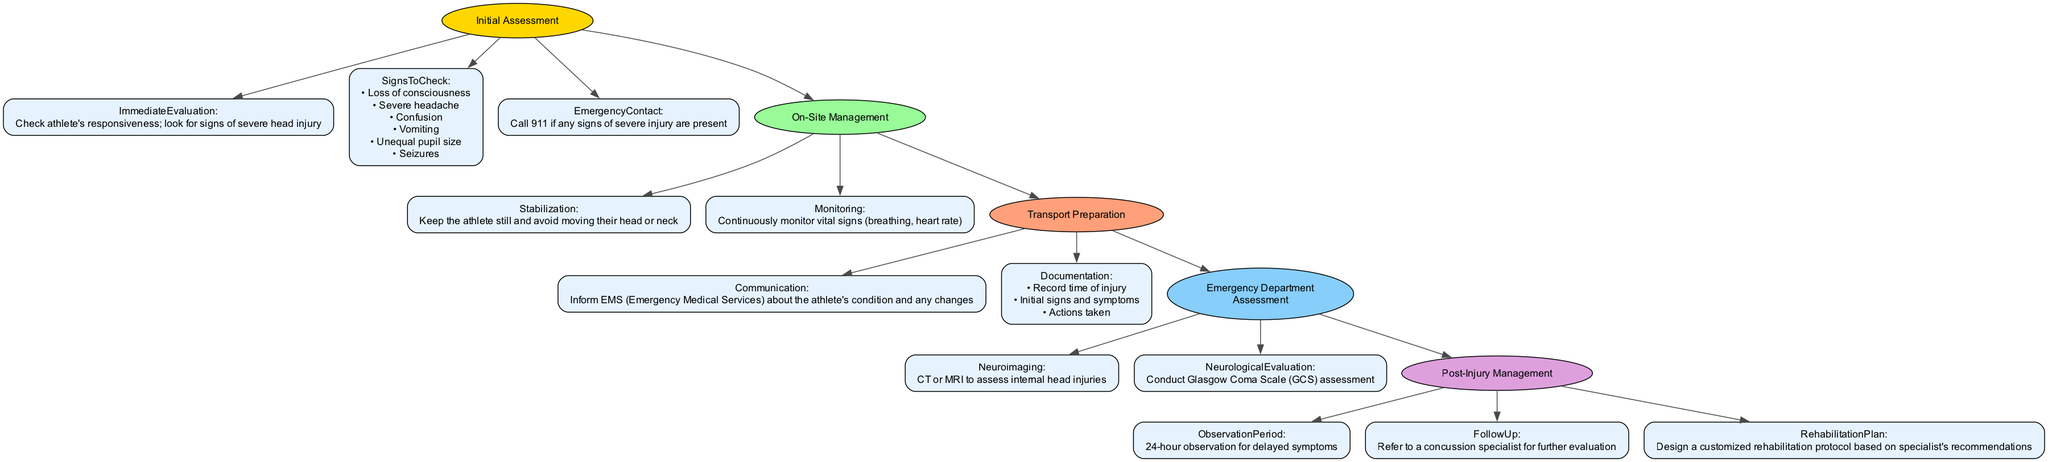What is the first step in the clinical pathway? The first step in the clinical pathway is "Initial Assessment," indicated as the starting node in the diagram.
Answer: Initial Assessment How many signs should be checked during the immediate evaluation? The immediate evaluation lists six signs to check, which are detailed in the corresponding node.
Answer: 6 What action should be taken if any signs of severe injury are present? The action to take is to "Call 911," which is noted in the Emergency Contact section of the Immediate Assessment.
Answer: Call 911 Which department conducts the neuroimaging? The neuroimaging is conducted in the "Emergency Department," as specified in the section pertaining to Emergency Department Assessment.
Answer: Emergency Department What is the observation period after a severe head injury? The diagram indicates that there is a "24-hour observation" period for delayed symptoms in the Post-Injury Management section.
Answer: 24-hour observation What does the stabilization protocol emphasize during on-site management? The stabilization protocol emphasizes "Keep the athlete still and avoid moving their head or neck," reflecting the importance of maintaining stability.
Answer: Keep the athlete still and avoid moving their head or neck What is required in the transport preparation phase regarding communication? It is required to "Inform EMS about the athlete's condition and any changes," which is highlighted in the Transport Preparation section.
Answer: Inform EMS about the athlete's condition and any changes What assessment tool is utilized during the neurological evaluation? The assessment tool utilized is the "Glasgow Coma Scale (GCS)," which is specifically mentioned in the Emergency Department Assessment section.
Answer: Glasgow Coma Scale (GCS) Which management step involves designing a rehabilitation protocol? The management step that involves designing a rehabilitation protocol is specified as "Rehabilitation Plan" in the Post-Injury Management section.
Answer: Rehabilitation Plan 